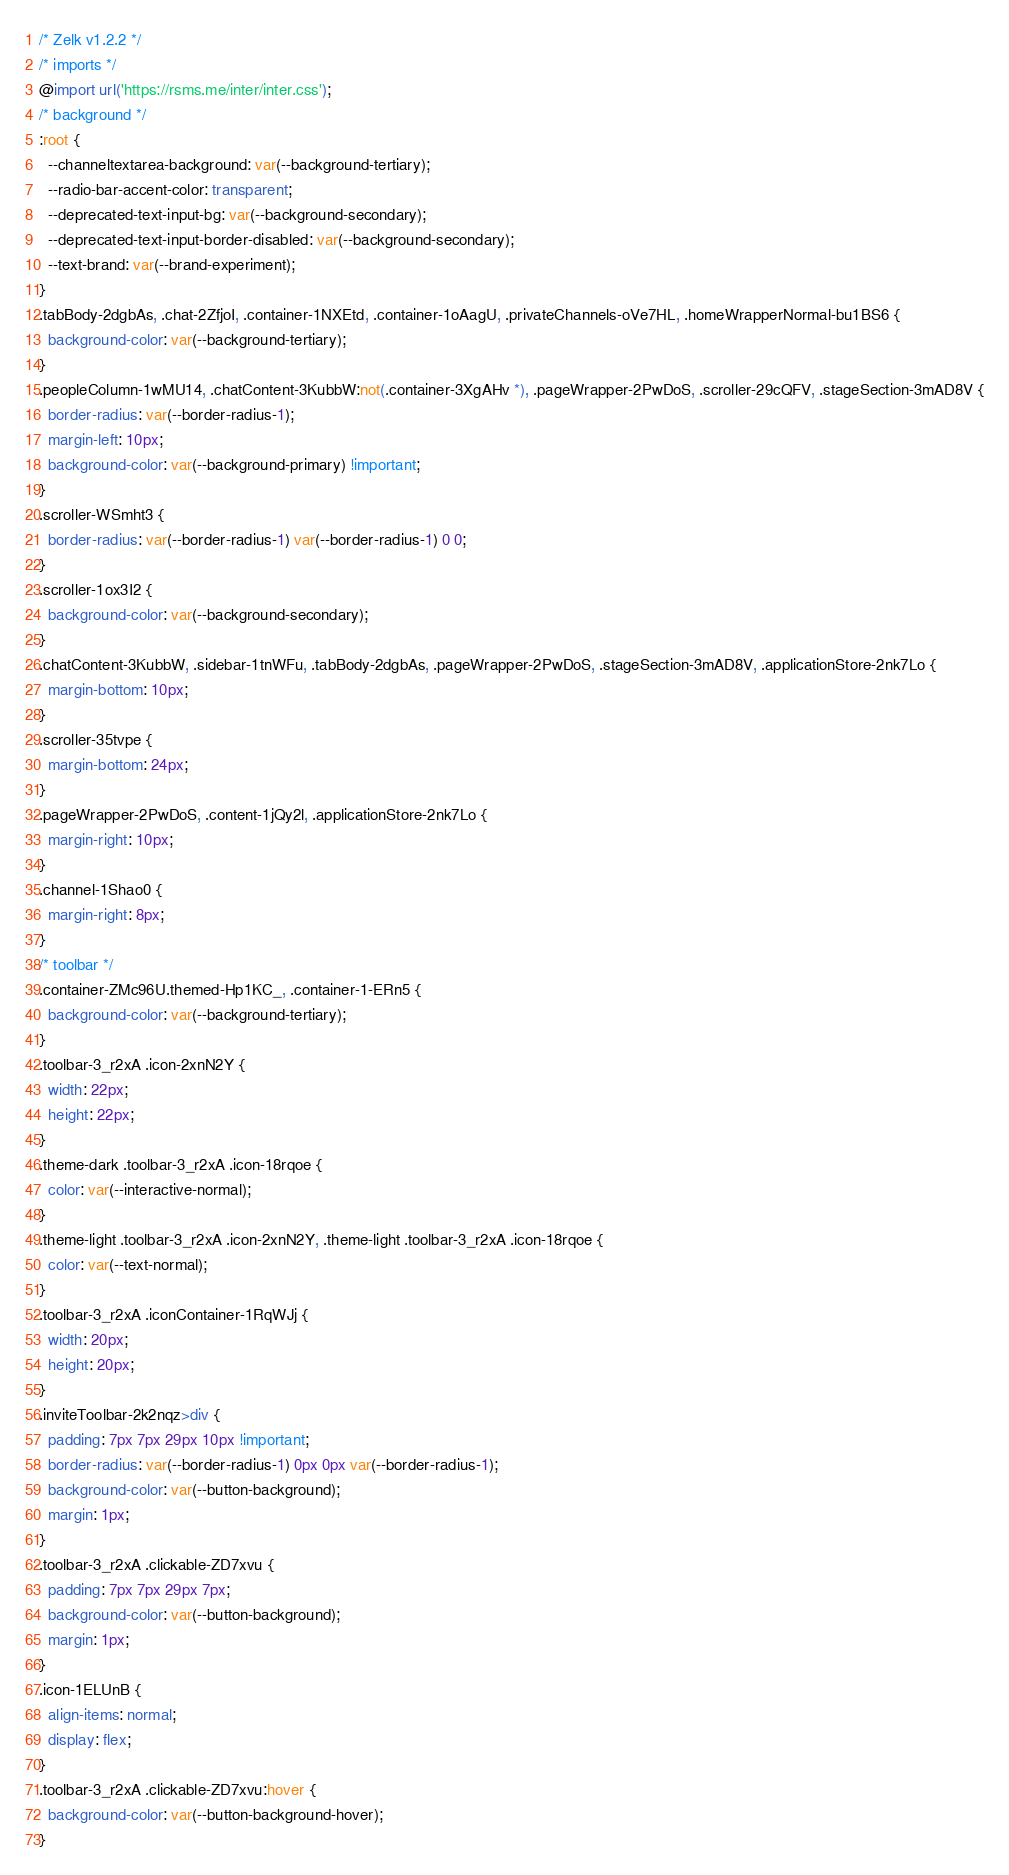Convert code to text. <code><loc_0><loc_0><loc_500><loc_500><_CSS_>/* Zelk v1.2.2 */
/* imports */
@import url('https://rsms.me/inter/inter.css');
/* background */
:root {
  --channeltextarea-background: var(--background-tertiary);
  --radio-bar-accent-color: transparent;
  --deprecated-text-input-bg: var(--background-secondary);
  --deprecated-text-input-border-disabled: var(--background-secondary);
  --text-brand: var(--brand-experiment);
}
.tabBody-2dgbAs, .chat-2ZfjoI, .container-1NXEtd, .container-1oAagU, .privateChannels-oVe7HL, .homeWrapperNormal-bu1BS6 {
  background-color: var(--background-tertiary);
}
.peopleColumn-1wMU14, .chatContent-3KubbW:not(.container-3XgAHv *), .pageWrapper-2PwDoS, .scroller-29cQFV, .stageSection-3mAD8V {
  border-radius: var(--border-radius-1);
  margin-left: 10px;
  background-color: var(--background-primary) !important;
}
.scroller-WSmht3 {
  border-radius: var(--border-radius-1) var(--border-radius-1) 0 0;
}
.scroller-1ox3I2 {
  background-color: var(--background-secondary);
}
.chatContent-3KubbW, .sidebar-1tnWFu, .tabBody-2dgbAs, .pageWrapper-2PwDoS, .stageSection-3mAD8V, .applicationStore-2nk7Lo {
  margin-bottom: 10px;
}
.scroller-35tvpe {
  margin-bottom: 24px;
}
.pageWrapper-2PwDoS, .content-1jQy2l, .applicationStore-2nk7Lo {
  margin-right: 10px;
}
.channel-1Shao0 {
  margin-right: 8px;
}
/* toolbar */
.container-ZMc96U.themed-Hp1KC_, .container-1-ERn5 {
  background-color: var(--background-tertiary);
}
.toolbar-3_r2xA .icon-2xnN2Y {
  width: 22px;
  height: 22px;
}
.theme-dark .toolbar-3_r2xA .icon-18rqoe {
  color: var(--interactive-normal);
}
.theme-light .toolbar-3_r2xA .icon-2xnN2Y, .theme-light .toolbar-3_r2xA .icon-18rqoe {
  color: var(--text-normal);
}
.toolbar-3_r2xA .iconContainer-1RqWJj {
  width: 20px;
  height: 20px;
}
.inviteToolbar-2k2nqz>div {
  padding: 7px 7px 29px 10px !important;
  border-radius: var(--border-radius-1) 0px 0px var(--border-radius-1);
  background-color: var(--button-background);
  margin: 1px;
}
.toolbar-3_r2xA .clickable-ZD7xvu {
  padding: 7px 7px 29px 7px;
  background-color: var(--button-background);
  margin: 1px;
}
.icon-1ELUnB {
  align-items: normal;
  display: flex;
}
.toolbar-3_r2xA .clickable-ZD7xvu:hover {
  background-color: var(--button-background-hover);
}</code> 